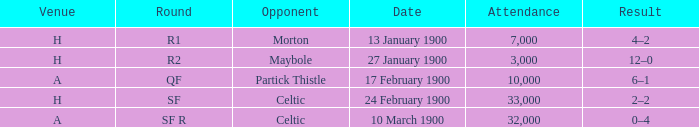What round did the celtic played away on 24 february 1900? SF. 